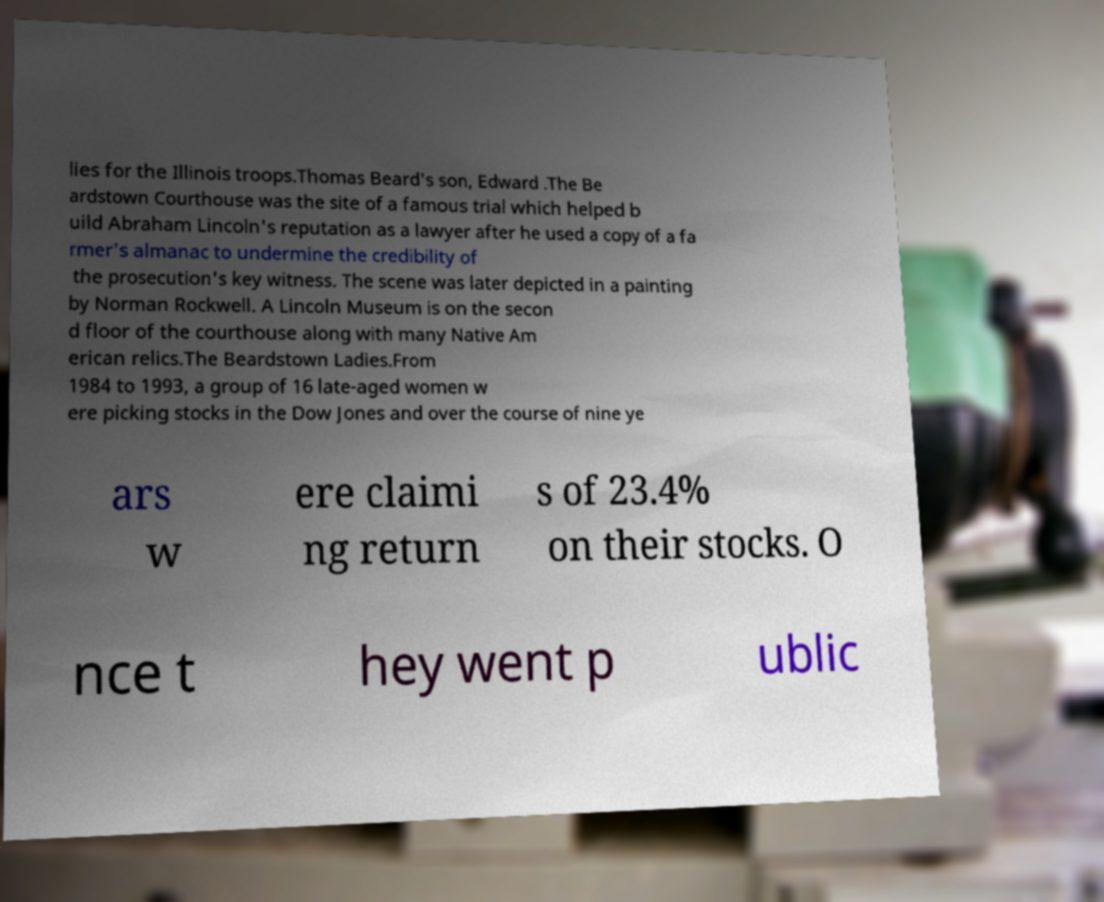Please identify and transcribe the text found in this image. lies for the Illinois troops.Thomas Beard's son, Edward .The Be ardstown Courthouse was the site of a famous trial which helped b uild Abraham Lincoln's reputation as a lawyer after he used a copy of a fa rmer's almanac to undermine the credibility of the prosecution's key witness. The scene was later depicted in a painting by Norman Rockwell. A Lincoln Museum is on the secon d floor of the courthouse along with many Native Am erican relics.The Beardstown Ladies.From 1984 to 1993, a group of 16 late-aged women w ere picking stocks in the Dow Jones and over the course of nine ye ars w ere claimi ng return s of 23.4% on their stocks. O nce t hey went p ublic 